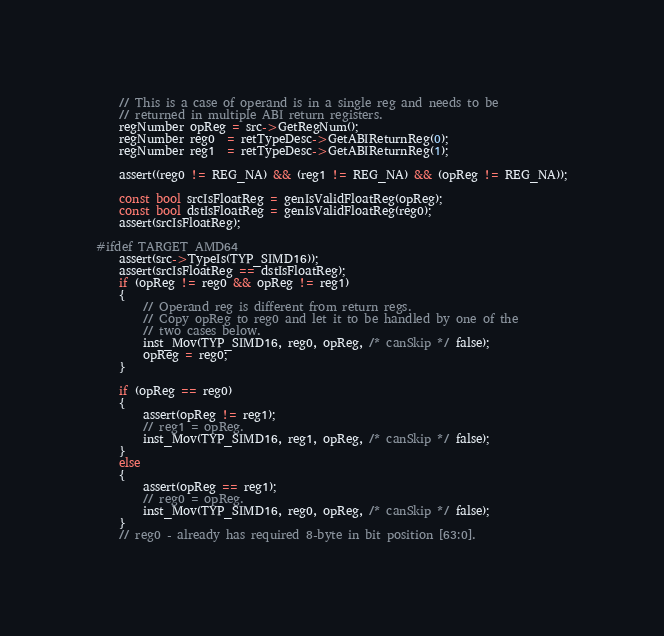Convert code to text. <code><loc_0><loc_0><loc_500><loc_500><_C++_>
    // This is a case of operand is in a single reg and needs to be
    // returned in multiple ABI return registers.
    regNumber opReg = src->GetRegNum();
    regNumber reg0  = retTypeDesc->GetABIReturnReg(0);
    regNumber reg1  = retTypeDesc->GetABIReturnReg(1);

    assert((reg0 != REG_NA) && (reg1 != REG_NA) && (opReg != REG_NA));

    const bool srcIsFloatReg = genIsValidFloatReg(opReg);
    const bool dstIsFloatReg = genIsValidFloatReg(reg0);
    assert(srcIsFloatReg);

#ifdef TARGET_AMD64
    assert(src->TypeIs(TYP_SIMD16));
    assert(srcIsFloatReg == dstIsFloatReg);
    if (opReg != reg0 && opReg != reg1)
    {
        // Operand reg is different from return regs.
        // Copy opReg to reg0 and let it to be handled by one of the
        // two cases below.
        inst_Mov(TYP_SIMD16, reg0, opReg, /* canSkip */ false);
        opReg = reg0;
    }

    if (opReg == reg0)
    {
        assert(opReg != reg1);
        // reg1 = opReg.
        inst_Mov(TYP_SIMD16, reg1, opReg, /* canSkip */ false);
    }
    else
    {
        assert(opReg == reg1);
        // reg0 = opReg.
        inst_Mov(TYP_SIMD16, reg0, opReg, /* canSkip */ false);
    }
    // reg0 - already has required 8-byte in bit position [63:0].</code> 